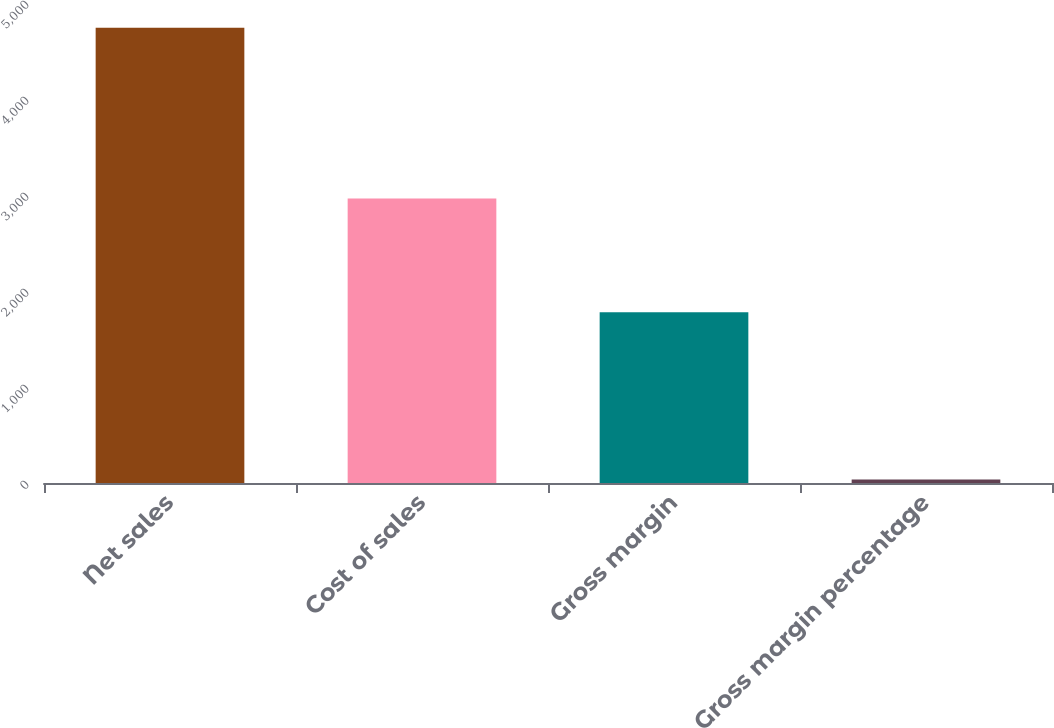Convert chart. <chart><loc_0><loc_0><loc_500><loc_500><bar_chart><fcel>Net sales<fcel>Cost of sales<fcel>Gross margin<fcel>Gross margin percentage<nl><fcel>4743.2<fcel>2964.7<fcel>1778.5<fcel>37.5<nl></chart> 